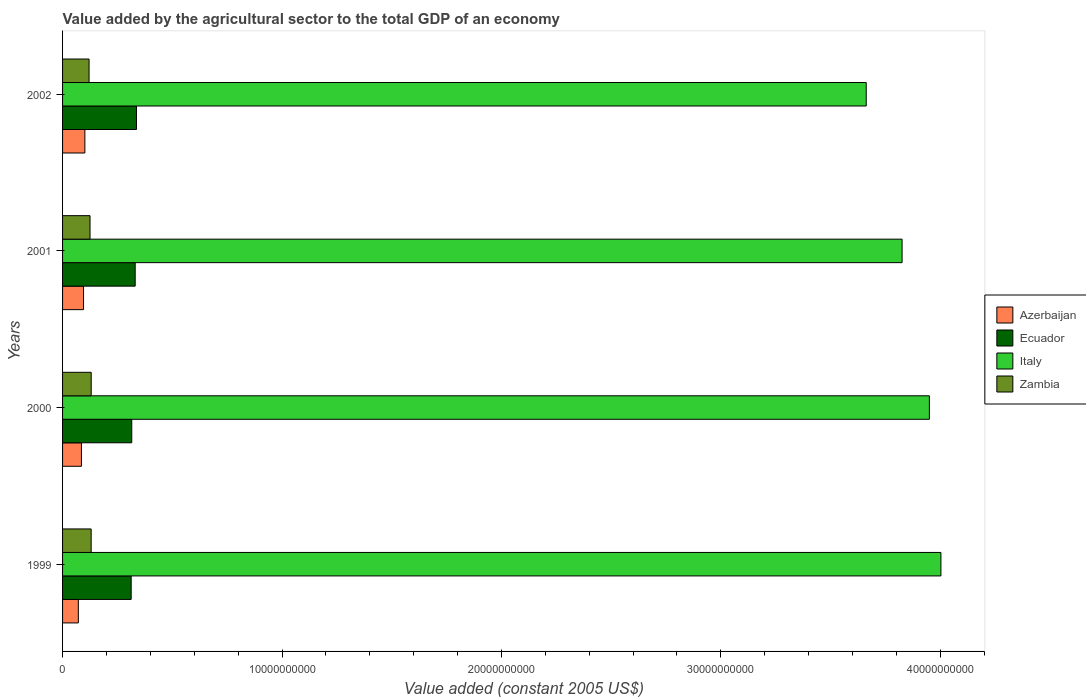How many groups of bars are there?
Your answer should be very brief. 4. Are the number of bars per tick equal to the number of legend labels?
Make the answer very short. Yes. How many bars are there on the 2nd tick from the top?
Your response must be concise. 4. How many bars are there on the 1st tick from the bottom?
Your answer should be compact. 4. In how many cases, is the number of bars for a given year not equal to the number of legend labels?
Provide a succinct answer. 0. What is the value added by the agricultural sector in Zambia in 2000?
Ensure brevity in your answer.  1.30e+09. Across all years, what is the maximum value added by the agricultural sector in Azerbaijan?
Give a very brief answer. 1.02e+09. Across all years, what is the minimum value added by the agricultural sector in Italy?
Keep it short and to the point. 3.66e+1. What is the total value added by the agricultural sector in Ecuador in the graph?
Offer a terse response. 1.30e+1. What is the difference between the value added by the agricultural sector in Zambia in 1999 and that in 2001?
Provide a succinct answer. 5.15e+07. What is the difference between the value added by the agricultural sector in Italy in 2001 and the value added by the agricultural sector in Zambia in 1999?
Your answer should be very brief. 3.70e+1. What is the average value added by the agricultural sector in Italy per year?
Give a very brief answer. 3.86e+1. In the year 2002, what is the difference between the value added by the agricultural sector in Ecuador and value added by the agricultural sector in Azerbaijan?
Your answer should be compact. 2.35e+09. In how many years, is the value added by the agricultural sector in Zambia greater than 34000000000 US$?
Give a very brief answer. 0. What is the ratio of the value added by the agricultural sector in Italy in 2001 to that in 2002?
Keep it short and to the point. 1.04. Is the value added by the agricultural sector in Italy in 1999 less than that in 2000?
Ensure brevity in your answer.  No. What is the difference between the highest and the second highest value added by the agricultural sector in Zambia?
Give a very brief answer. 2.15e+06. What is the difference between the highest and the lowest value added by the agricultural sector in Italy?
Offer a terse response. 3.40e+09. In how many years, is the value added by the agricultural sector in Zambia greater than the average value added by the agricultural sector in Zambia taken over all years?
Provide a succinct answer. 2. What does the 3rd bar from the top in 1999 represents?
Provide a succinct answer. Ecuador. What does the 2nd bar from the bottom in 2000 represents?
Offer a terse response. Ecuador. Are all the bars in the graph horizontal?
Make the answer very short. Yes. What is the difference between two consecutive major ticks on the X-axis?
Your answer should be very brief. 1.00e+1. Are the values on the major ticks of X-axis written in scientific E-notation?
Offer a very short reply. No. How many legend labels are there?
Offer a very short reply. 4. How are the legend labels stacked?
Keep it short and to the point. Vertical. What is the title of the graph?
Ensure brevity in your answer.  Value added by the agricultural sector to the total GDP of an economy. What is the label or title of the X-axis?
Offer a very short reply. Value added (constant 2005 US$). What is the label or title of the Y-axis?
Offer a very short reply. Years. What is the Value added (constant 2005 US$) in Azerbaijan in 1999?
Offer a terse response. 7.19e+08. What is the Value added (constant 2005 US$) in Ecuador in 1999?
Keep it short and to the point. 3.13e+09. What is the Value added (constant 2005 US$) in Italy in 1999?
Your answer should be very brief. 4.00e+1. What is the Value added (constant 2005 US$) in Zambia in 1999?
Your answer should be compact. 1.30e+09. What is the Value added (constant 2005 US$) of Azerbaijan in 2000?
Offer a very short reply. 8.60e+08. What is the Value added (constant 2005 US$) of Ecuador in 2000?
Provide a short and direct response. 3.15e+09. What is the Value added (constant 2005 US$) of Italy in 2000?
Provide a short and direct response. 3.95e+1. What is the Value added (constant 2005 US$) in Zambia in 2000?
Ensure brevity in your answer.  1.30e+09. What is the Value added (constant 2005 US$) in Azerbaijan in 2001?
Give a very brief answer. 9.55e+08. What is the Value added (constant 2005 US$) of Ecuador in 2001?
Keep it short and to the point. 3.31e+09. What is the Value added (constant 2005 US$) in Italy in 2001?
Your answer should be very brief. 3.83e+1. What is the Value added (constant 2005 US$) of Zambia in 2001?
Ensure brevity in your answer.  1.25e+09. What is the Value added (constant 2005 US$) in Azerbaijan in 2002?
Give a very brief answer. 1.02e+09. What is the Value added (constant 2005 US$) of Ecuador in 2002?
Your answer should be very brief. 3.37e+09. What is the Value added (constant 2005 US$) in Italy in 2002?
Give a very brief answer. 3.66e+1. What is the Value added (constant 2005 US$) in Zambia in 2002?
Give a very brief answer. 1.21e+09. Across all years, what is the maximum Value added (constant 2005 US$) in Azerbaijan?
Your answer should be compact. 1.02e+09. Across all years, what is the maximum Value added (constant 2005 US$) in Ecuador?
Provide a short and direct response. 3.37e+09. Across all years, what is the maximum Value added (constant 2005 US$) in Italy?
Offer a very short reply. 4.00e+1. Across all years, what is the maximum Value added (constant 2005 US$) in Zambia?
Offer a terse response. 1.30e+09. Across all years, what is the minimum Value added (constant 2005 US$) of Azerbaijan?
Make the answer very short. 7.19e+08. Across all years, what is the minimum Value added (constant 2005 US$) in Ecuador?
Your answer should be very brief. 3.13e+09. Across all years, what is the minimum Value added (constant 2005 US$) in Italy?
Make the answer very short. 3.66e+1. Across all years, what is the minimum Value added (constant 2005 US$) of Zambia?
Keep it short and to the point. 1.21e+09. What is the total Value added (constant 2005 US$) in Azerbaijan in the graph?
Offer a terse response. 3.55e+09. What is the total Value added (constant 2005 US$) of Ecuador in the graph?
Make the answer very short. 1.30e+1. What is the total Value added (constant 2005 US$) in Italy in the graph?
Your answer should be very brief. 1.54e+11. What is the total Value added (constant 2005 US$) of Zambia in the graph?
Provide a short and direct response. 5.07e+09. What is the difference between the Value added (constant 2005 US$) in Azerbaijan in 1999 and that in 2000?
Provide a succinct answer. -1.41e+08. What is the difference between the Value added (constant 2005 US$) of Ecuador in 1999 and that in 2000?
Keep it short and to the point. -2.61e+07. What is the difference between the Value added (constant 2005 US$) of Italy in 1999 and that in 2000?
Ensure brevity in your answer.  5.26e+08. What is the difference between the Value added (constant 2005 US$) of Zambia in 1999 and that in 2000?
Offer a very short reply. -2.15e+06. What is the difference between the Value added (constant 2005 US$) in Azerbaijan in 1999 and that in 2001?
Make the answer very short. -2.36e+08. What is the difference between the Value added (constant 2005 US$) in Ecuador in 1999 and that in 2001?
Provide a short and direct response. -1.83e+08. What is the difference between the Value added (constant 2005 US$) in Italy in 1999 and that in 2001?
Make the answer very short. 1.77e+09. What is the difference between the Value added (constant 2005 US$) of Zambia in 1999 and that in 2001?
Offer a terse response. 5.15e+07. What is the difference between the Value added (constant 2005 US$) of Azerbaijan in 1999 and that in 2002?
Your answer should be very brief. -2.97e+08. What is the difference between the Value added (constant 2005 US$) in Ecuador in 1999 and that in 2002?
Your answer should be compact. -2.41e+08. What is the difference between the Value added (constant 2005 US$) of Italy in 1999 and that in 2002?
Provide a succinct answer. 3.40e+09. What is the difference between the Value added (constant 2005 US$) in Zambia in 1999 and that in 2002?
Keep it short and to the point. 9.56e+07. What is the difference between the Value added (constant 2005 US$) of Azerbaijan in 2000 and that in 2001?
Offer a terse response. -9.54e+07. What is the difference between the Value added (constant 2005 US$) of Ecuador in 2000 and that in 2001?
Provide a succinct answer. -1.57e+08. What is the difference between the Value added (constant 2005 US$) of Italy in 2000 and that in 2001?
Your answer should be very brief. 1.24e+09. What is the difference between the Value added (constant 2005 US$) of Zambia in 2000 and that in 2001?
Your answer should be compact. 5.36e+07. What is the difference between the Value added (constant 2005 US$) in Azerbaijan in 2000 and that in 2002?
Provide a succinct answer. -1.57e+08. What is the difference between the Value added (constant 2005 US$) in Ecuador in 2000 and that in 2002?
Offer a terse response. -2.15e+08. What is the difference between the Value added (constant 2005 US$) in Italy in 2000 and that in 2002?
Offer a very short reply. 2.88e+09. What is the difference between the Value added (constant 2005 US$) in Zambia in 2000 and that in 2002?
Provide a succinct answer. 9.78e+07. What is the difference between the Value added (constant 2005 US$) in Azerbaijan in 2001 and that in 2002?
Ensure brevity in your answer.  -6.11e+07. What is the difference between the Value added (constant 2005 US$) in Ecuador in 2001 and that in 2002?
Offer a terse response. -5.85e+07. What is the difference between the Value added (constant 2005 US$) of Italy in 2001 and that in 2002?
Make the answer very short. 1.63e+09. What is the difference between the Value added (constant 2005 US$) in Zambia in 2001 and that in 2002?
Provide a succinct answer. 4.41e+07. What is the difference between the Value added (constant 2005 US$) in Azerbaijan in 1999 and the Value added (constant 2005 US$) in Ecuador in 2000?
Your response must be concise. -2.43e+09. What is the difference between the Value added (constant 2005 US$) in Azerbaijan in 1999 and the Value added (constant 2005 US$) in Italy in 2000?
Make the answer very short. -3.88e+1. What is the difference between the Value added (constant 2005 US$) of Azerbaijan in 1999 and the Value added (constant 2005 US$) of Zambia in 2000?
Ensure brevity in your answer.  -5.86e+08. What is the difference between the Value added (constant 2005 US$) in Ecuador in 1999 and the Value added (constant 2005 US$) in Italy in 2000?
Provide a short and direct response. -3.64e+1. What is the difference between the Value added (constant 2005 US$) in Ecuador in 1999 and the Value added (constant 2005 US$) in Zambia in 2000?
Your answer should be very brief. 1.82e+09. What is the difference between the Value added (constant 2005 US$) of Italy in 1999 and the Value added (constant 2005 US$) of Zambia in 2000?
Keep it short and to the point. 3.87e+1. What is the difference between the Value added (constant 2005 US$) of Azerbaijan in 1999 and the Value added (constant 2005 US$) of Ecuador in 2001?
Your answer should be very brief. -2.59e+09. What is the difference between the Value added (constant 2005 US$) of Azerbaijan in 1999 and the Value added (constant 2005 US$) of Italy in 2001?
Provide a short and direct response. -3.75e+1. What is the difference between the Value added (constant 2005 US$) of Azerbaijan in 1999 and the Value added (constant 2005 US$) of Zambia in 2001?
Your answer should be very brief. -5.32e+08. What is the difference between the Value added (constant 2005 US$) of Ecuador in 1999 and the Value added (constant 2005 US$) of Italy in 2001?
Make the answer very short. -3.51e+1. What is the difference between the Value added (constant 2005 US$) in Ecuador in 1999 and the Value added (constant 2005 US$) in Zambia in 2001?
Ensure brevity in your answer.  1.88e+09. What is the difference between the Value added (constant 2005 US$) of Italy in 1999 and the Value added (constant 2005 US$) of Zambia in 2001?
Your response must be concise. 3.88e+1. What is the difference between the Value added (constant 2005 US$) in Azerbaijan in 1999 and the Value added (constant 2005 US$) in Ecuador in 2002?
Provide a short and direct response. -2.65e+09. What is the difference between the Value added (constant 2005 US$) of Azerbaijan in 1999 and the Value added (constant 2005 US$) of Italy in 2002?
Give a very brief answer. -3.59e+1. What is the difference between the Value added (constant 2005 US$) of Azerbaijan in 1999 and the Value added (constant 2005 US$) of Zambia in 2002?
Provide a short and direct response. -4.88e+08. What is the difference between the Value added (constant 2005 US$) of Ecuador in 1999 and the Value added (constant 2005 US$) of Italy in 2002?
Your answer should be very brief. -3.35e+1. What is the difference between the Value added (constant 2005 US$) in Ecuador in 1999 and the Value added (constant 2005 US$) in Zambia in 2002?
Your answer should be very brief. 1.92e+09. What is the difference between the Value added (constant 2005 US$) of Italy in 1999 and the Value added (constant 2005 US$) of Zambia in 2002?
Offer a very short reply. 3.88e+1. What is the difference between the Value added (constant 2005 US$) of Azerbaijan in 2000 and the Value added (constant 2005 US$) of Ecuador in 2001?
Provide a short and direct response. -2.45e+09. What is the difference between the Value added (constant 2005 US$) in Azerbaijan in 2000 and the Value added (constant 2005 US$) in Italy in 2001?
Your answer should be very brief. -3.74e+1. What is the difference between the Value added (constant 2005 US$) of Azerbaijan in 2000 and the Value added (constant 2005 US$) of Zambia in 2001?
Offer a terse response. -3.91e+08. What is the difference between the Value added (constant 2005 US$) of Ecuador in 2000 and the Value added (constant 2005 US$) of Italy in 2001?
Your answer should be compact. -3.51e+1. What is the difference between the Value added (constant 2005 US$) of Ecuador in 2000 and the Value added (constant 2005 US$) of Zambia in 2001?
Make the answer very short. 1.90e+09. What is the difference between the Value added (constant 2005 US$) of Italy in 2000 and the Value added (constant 2005 US$) of Zambia in 2001?
Make the answer very short. 3.83e+1. What is the difference between the Value added (constant 2005 US$) of Azerbaijan in 2000 and the Value added (constant 2005 US$) of Ecuador in 2002?
Provide a succinct answer. -2.51e+09. What is the difference between the Value added (constant 2005 US$) of Azerbaijan in 2000 and the Value added (constant 2005 US$) of Italy in 2002?
Ensure brevity in your answer.  -3.58e+1. What is the difference between the Value added (constant 2005 US$) of Azerbaijan in 2000 and the Value added (constant 2005 US$) of Zambia in 2002?
Keep it short and to the point. -3.47e+08. What is the difference between the Value added (constant 2005 US$) of Ecuador in 2000 and the Value added (constant 2005 US$) of Italy in 2002?
Ensure brevity in your answer.  -3.35e+1. What is the difference between the Value added (constant 2005 US$) in Ecuador in 2000 and the Value added (constant 2005 US$) in Zambia in 2002?
Your answer should be compact. 1.95e+09. What is the difference between the Value added (constant 2005 US$) in Italy in 2000 and the Value added (constant 2005 US$) in Zambia in 2002?
Your response must be concise. 3.83e+1. What is the difference between the Value added (constant 2005 US$) of Azerbaijan in 2001 and the Value added (constant 2005 US$) of Ecuador in 2002?
Your answer should be very brief. -2.41e+09. What is the difference between the Value added (constant 2005 US$) of Azerbaijan in 2001 and the Value added (constant 2005 US$) of Italy in 2002?
Your answer should be compact. -3.57e+1. What is the difference between the Value added (constant 2005 US$) in Azerbaijan in 2001 and the Value added (constant 2005 US$) in Zambia in 2002?
Offer a very short reply. -2.52e+08. What is the difference between the Value added (constant 2005 US$) of Ecuador in 2001 and the Value added (constant 2005 US$) of Italy in 2002?
Your answer should be very brief. -3.33e+1. What is the difference between the Value added (constant 2005 US$) of Ecuador in 2001 and the Value added (constant 2005 US$) of Zambia in 2002?
Provide a short and direct response. 2.10e+09. What is the difference between the Value added (constant 2005 US$) in Italy in 2001 and the Value added (constant 2005 US$) in Zambia in 2002?
Provide a short and direct response. 3.71e+1. What is the average Value added (constant 2005 US$) in Azerbaijan per year?
Your response must be concise. 8.88e+08. What is the average Value added (constant 2005 US$) of Ecuador per year?
Keep it short and to the point. 3.24e+09. What is the average Value added (constant 2005 US$) of Italy per year?
Your answer should be very brief. 3.86e+1. What is the average Value added (constant 2005 US$) in Zambia per year?
Your answer should be compact. 1.27e+09. In the year 1999, what is the difference between the Value added (constant 2005 US$) in Azerbaijan and Value added (constant 2005 US$) in Ecuador?
Offer a terse response. -2.41e+09. In the year 1999, what is the difference between the Value added (constant 2005 US$) in Azerbaijan and Value added (constant 2005 US$) in Italy?
Your answer should be very brief. -3.93e+1. In the year 1999, what is the difference between the Value added (constant 2005 US$) of Azerbaijan and Value added (constant 2005 US$) of Zambia?
Your answer should be very brief. -5.84e+08. In the year 1999, what is the difference between the Value added (constant 2005 US$) of Ecuador and Value added (constant 2005 US$) of Italy?
Your answer should be very brief. -3.69e+1. In the year 1999, what is the difference between the Value added (constant 2005 US$) in Ecuador and Value added (constant 2005 US$) in Zambia?
Your answer should be very brief. 1.82e+09. In the year 1999, what is the difference between the Value added (constant 2005 US$) of Italy and Value added (constant 2005 US$) of Zambia?
Provide a short and direct response. 3.87e+1. In the year 2000, what is the difference between the Value added (constant 2005 US$) of Azerbaijan and Value added (constant 2005 US$) of Ecuador?
Provide a succinct answer. -2.29e+09. In the year 2000, what is the difference between the Value added (constant 2005 US$) of Azerbaijan and Value added (constant 2005 US$) of Italy?
Offer a terse response. -3.86e+1. In the year 2000, what is the difference between the Value added (constant 2005 US$) of Azerbaijan and Value added (constant 2005 US$) of Zambia?
Provide a succinct answer. -4.45e+08. In the year 2000, what is the difference between the Value added (constant 2005 US$) of Ecuador and Value added (constant 2005 US$) of Italy?
Offer a terse response. -3.63e+1. In the year 2000, what is the difference between the Value added (constant 2005 US$) of Ecuador and Value added (constant 2005 US$) of Zambia?
Provide a short and direct response. 1.85e+09. In the year 2000, what is the difference between the Value added (constant 2005 US$) in Italy and Value added (constant 2005 US$) in Zambia?
Keep it short and to the point. 3.82e+1. In the year 2001, what is the difference between the Value added (constant 2005 US$) in Azerbaijan and Value added (constant 2005 US$) in Ecuador?
Keep it short and to the point. -2.35e+09. In the year 2001, what is the difference between the Value added (constant 2005 US$) in Azerbaijan and Value added (constant 2005 US$) in Italy?
Provide a short and direct response. -3.73e+1. In the year 2001, what is the difference between the Value added (constant 2005 US$) of Azerbaijan and Value added (constant 2005 US$) of Zambia?
Provide a short and direct response. -2.96e+08. In the year 2001, what is the difference between the Value added (constant 2005 US$) of Ecuador and Value added (constant 2005 US$) of Italy?
Make the answer very short. -3.49e+1. In the year 2001, what is the difference between the Value added (constant 2005 US$) of Ecuador and Value added (constant 2005 US$) of Zambia?
Provide a short and direct response. 2.06e+09. In the year 2001, what is the difference between the Value added (constant 2005 US$) of Italy and Value added (constant 2005 US$) of Zambia?
Keep it short and to the point. 3.70e+1. In the year 2002, what is the difference between the Value added (constant 2005 US$) in Azerbaijan and Value added (constant 2005 US$) in Ecuador?
Give a very brief answer. -2.35e+09. In the year 2002, what is the difference between the Value added (constant 2005 US$) in Azerbaijan and Value added (constant 2005 US$) in Italy?
Make the answer very short. -3.56e+1. In the year 2002, what is the difference between the Value added (constant 2005 US$) of Azerbaijan and Value added (constant 2005 US$) of Zambia?
Ensure brevity in your answer.  -1.91e+08. In the year 2002, what is the difference between the Value added (constant 2005 US$) in Ecuador and Value added (constant 2005 US$) in Italy?
Give a very brief answer. -3.33e+1. In the year 2002, what is the difference between the Value added (constant 2005 US$) in Ecuador and Value added (constant 2005 US$) in Zambia?
Offer a terse response. 2.16e+09. In the year 2002, what is the difference between the Value added (constant 2005 US$) of Italy and Value added (constant 2005 US$) of Zambia?
Your answer should be compact. 3.54e+1. What is the ratio of the Value added (constant 2005 US$) in Azerbaijan in 1999 to that in 2000?
Offer a terse response. 0.84. What is the ratio of the Value added (constant 2005 US$) in Italy in 1999 to that in 2000?
Keep it short and to the point. 1.01. What is the ratio of the Value added (constant 2005 US$) of Azerbaijan in 1999 to that in 2001?
Provide a short and direct response. 0.75. What is the ratio of the Value added (constant 2005 US$) in Ecuador in 1999 to that in 2001?
Keep it short and to the point. 0.94. What is the ratio of the Value added (constant 2005 US$) in Italy in 1999 to that in 2001?
Provide a succinct answer. 1.05. What is the ratio of the Value added (constant 2005 US$) in Zambia in 1999 to that in 2001?
Make the answer very short. 1.04. What is the ratio of the Value added (constant 2005 US$) of Azerbaijan in 1999 to that in 2002?
Keep it short and to the point. 0.71. What is the ratio of the Value added (constant 2005 US$) of Ecuador in 1999 to that in 2002?
Your response must be concise. 0.93. What is the ratio of the Value added (constant 2005 US$) in Italy in 1999 to that in 2002?
Your response must be concise. 1.09. What is the ratio of the Value added (constant 2005 US$) in Zambia in 1999 to that in 2002?
Make the answer very short. 1.08. What is the ratio of the Value added (constant 2005 US$) of Azerbaijan in 2000 to that in 2001?
Provide a succinct answer. 0.9. What is the ratio of the Value added (constant 2005 US$) of Ecuador in 2000 to that in 2001?
Make the answer very short. 0.95. What is the ratio of the Value added (constant 2005 US$) in Italy in 2000 to that in 2001?
Keep it short and to the point. 1.03. What is the ratio of the Value added (constant 2005 US$) in Zambia in 2000 to that in 2001?
Offer a very short reply. 1.04. What is the ratio of the Value added (constant 2005 US$) in Azerbaijan in 2000 to that in 2002?
Provide a short and direct response. 0.85. What is the ratio of the Value added (constant 2005 US$) of Ecuador in 2000 to that in 2002?
Your answer should be compact. 0.94. What is the ratio of the Value added (constant 2005 US$) in Italy in 2000 to that in 2002?
Your response must be concise. 1.08. What is the ratio of the Value added (constant 2005 US$) of Zambia in 2000 to that in 2002?
Your answer should be very brief. 1.08. What is the ratio of the Value added (constant 2005 US$) of Azerbaijan in 2001 to that in 2002?
Offer a terse response. 0.94. What is the ratio of the Value added (constant 2005 US$) of Ecuador in 2001 to that in 2002?
Make the answer very short. 0.98. What is the ratio of the Value added (constant 2005 US$) in Italy in 2001 to that in 2002?
Your answer should be very brief. 1.04. What is the ratio of the Value added (constant 2005 US$) in Zambia in 2001 to that in 2002?
Keep it short and to the point. 1.04. What is the difference between the highest and the second highest Value added (constant 2005 US$) in Azerbaijan?
Offer a very short reply. 6.11e+07. What is the difference between the highest and the second highest Value added (constant 2005 US$) of Ecuador?
Offer a terse response. 5.85e+07. What is the difference between the highest and the second highest Value added (constant 2005 US$) in Italy?
Your answer should be compact. 5.26e+08. What is the difference between the highest and the second highest Value added (constant 2005 US$) in Zambia?
Ensure brevity in your answer.  2.15e+06. What is the difference between the highest and the lowest Value added (constant 2005 US$) of Azerbaijan?
Offer a terse response. 2.97e+08. What is the difference between the highest and the lowest Value added (constant 2005 US$) in Ecuador?
Offer a terse response. 2.41e+08. What is the difference between the highest and the lowest Value added (constant 2005 US$) in Italy?
Provide a short and direct response. 3.40e+09. What is the difference between the highest and the lowest Value added (constant 2005 US$) of Zambia?
Ensure brevity in your answer.  9.78e+07. 